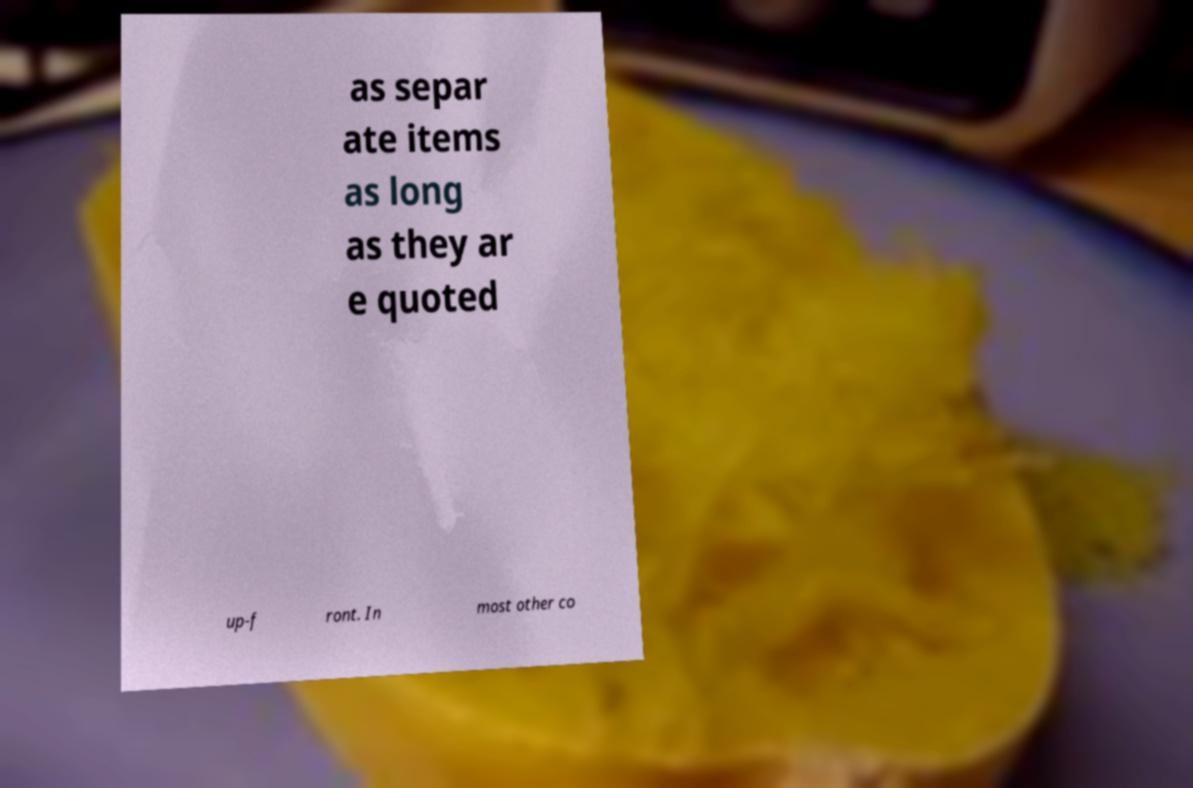For documentation purposes, I need the text within this image transcribed. Could you provide that? as separ ate items as long as they ar e quoted up-f ront. In most other co 